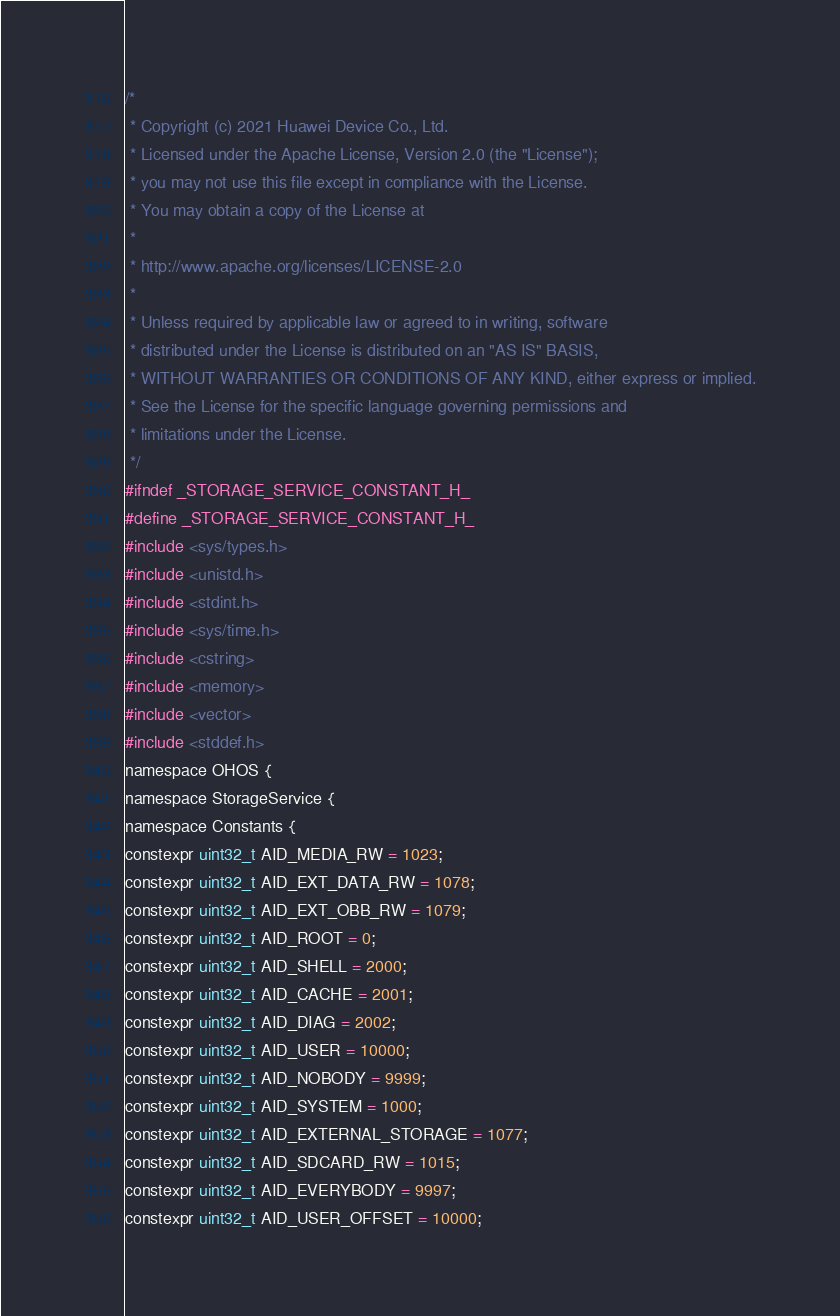<code> <loc_0><loc_0><loc_500><loc_500><_C_>/*
 * Copyright (c) 2021 Huawei Device Co., Ltd.
 * Licensed under the Apache License, Version 2.0 (the "License");
 * you may not use this file except in compliance with the License.
 * You may obtain a copy of the License at
 *
 * http://www.apache.org/licenses/LICENSE-2.0
 *
 * Unless required by applicable law or agreed to in writing, software
 * distributed under the License is distributed on an "AS IS" BASIS,
 * WITHOUT WARRANTIES OR CONDITIONS OF ANY KIND, either express or implied.
 * See the License for the specific language governing permissions and
 * limitations under the License.
 */
#ifndef _STORAGE_SERVICE_CONSTANT_H_
#define _STORAGE_SERVICE_CONSTANT_H_
#include <sys/types.h>
#include <unistd.h>
#include <stdint.h>
#include <sys/time.h>
#include <cstring>
#include <memory>
#include <vector>
#include <stddef.h>
namespace OHOS {
namespace StorageService {
namespace Constants {
constexpr uint32_t AID_MEDIA_RW = 1023;
constexpr uint32_t AID_EXT_DATA_RW = 1078;
constexpr uint32_t AID_EXT_OBB_RW = 1079;
constexpr uint32_t AID_ROOT = 0;
constexpr uint32_t AID_SHELL = 2000;
constexpr uint32_t AID_CACHE = 2001;
constexpr uint32_t AID_DIAG = 2002;
constexpr uint32_t AID_USER = 10000;
constexpr uint32_t AID_NOBODY = 9999;
constexpr uint32_t AID_SYSTEM = 1000;
constexpr uint32_t AID_EXTERNAL_STORAGE = 1077;
constexpr uint32_t AID_SDCARD_RW = 1015;
constexpr uint32_t AID_EVERYBODY = 9997;
constexpr uint32_t AID_USER_OFFSET = 10000;</code> 